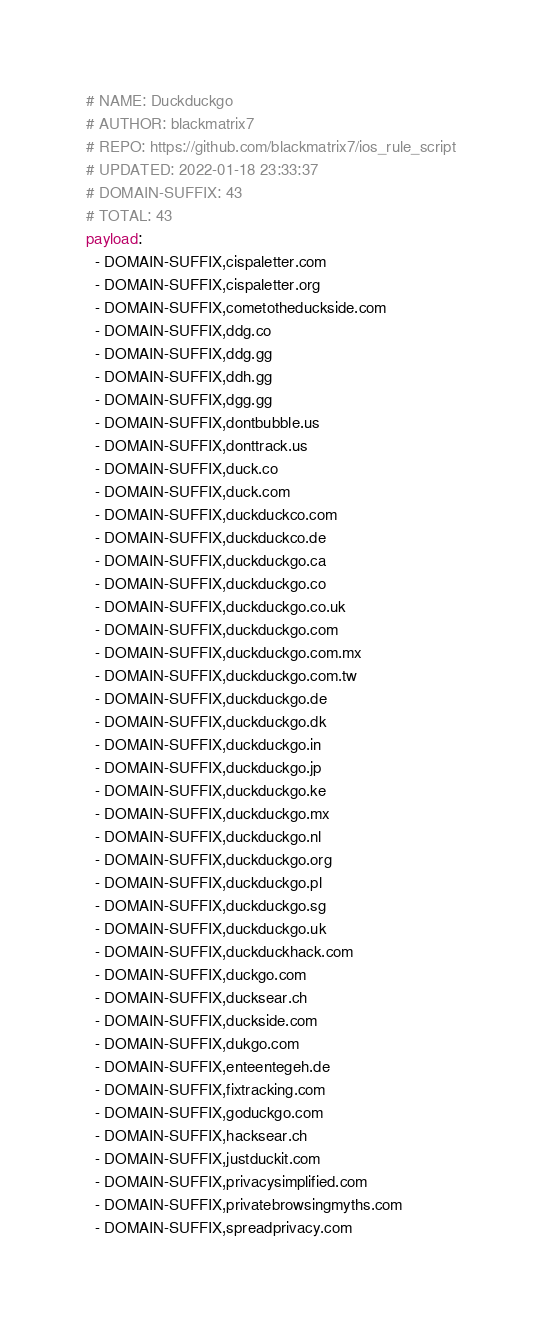Convert code to text. <code><loc_0><loc_0><loc_500><loc_500><_YAML_># NAME: Duckduckgo
# AUTHOR: blackmatrix7
# REPO: https://github.com/blackmatrix7/ios_rule_script
# UPDATED: 2022-01-18 23:33:37
# DOMAIN-SUFFIX: 43
# TOTAL: 43
payload:
  - DOMAIN-SUFFIX,cispaletter.com
  - DOMAIN-SUFFIX,cispaletter.org
  - DOMAIN-SUFFIX,cometotheduckside.com
  - DOMAIN-SUFFIX,ddg.co
  - DOMAIN-SUFFIX,ddg.gg
  - DOMAIN-SUFFIX,ddh.gg
  - DOMAIN-SUFFIX,dgg.gg
  - DOMAIN-SUFFIX,dontbubble.us
  - DOMAIN-SUFFIX,donttrack.us
  - DOMAIN-SUFFIX,duck.co
  - DOMAIN-SUFFIX,duck.com
  - DOMAIN-SUFFIX,duckduckco.com
  - DOMAIN-SUFFIX,duckduckco.de
  - DOMAIN-SUFFIX,duckduckgo.ca
  - DOMAIN-SUFFIX,duckduckgo.co
  - DOMAIN-SUFFIX,duckduckgo.co.uk
  - DOMAIN-SUFFIX,duckduckgo.com
  - DOMAIN-SUFFIX,duckduckgo.com.mx
  - DOMAIN-SUFFIX,duckduckgo.com.tw
  - DOMAIN-SUFFIX,duckduckgo.de
  - DOMAIN-SUFFIX,duckduckgo.dk
  - DOMAIN-SUFFIX,duckduckgo.in
  - DOMAIN-SUFFIX,duckduckgo.jp
  - DOMAIN-SUFFIX,duckduckgo.ke
  - DOMAIN-SUFFIX,duckduckgo.mx
  - DOMAIN-SUFFIX,duckduckgo.nl
  - DOMAIN-SUFFIX,duckduckgo.org
  - DOMAIN-SUFFIX,duckduckgo.pl
  - DOMAIN-SUFFIX,duckduckgo.sg
  - DOMAIN-SUFFIX,duckduckgo.uk
  - DOMAIN-SUFFIX,duckduckhack.com
  - DOMAIN-SUFFIX,duckgo.com
  - DOMAIN-SUFFIX,ducksear.ch
  - DOMAIN-SUFFIX,duckside.com
  - DOMAIN-SUFFIX,dukgo.com
  - DOMAIN-SUFFIX,enteentegeh.de
  - DOMAIN-SUFFIX,fixtracking.com
  - DOMAIN-SUFFIX,goduckgo.com
  - DOMAIN-SUFFIX,hacksear.ch
  - DOMAIN-SUFFIX,justduckit.com
  - DOMAIN-SUFFIX,privacysimplified.com
  - DOMAIN-SUFFIX,privatebrowsingmyths.com
  - DOMAIN-SUFFIX,spreadprivacy.com</code> 